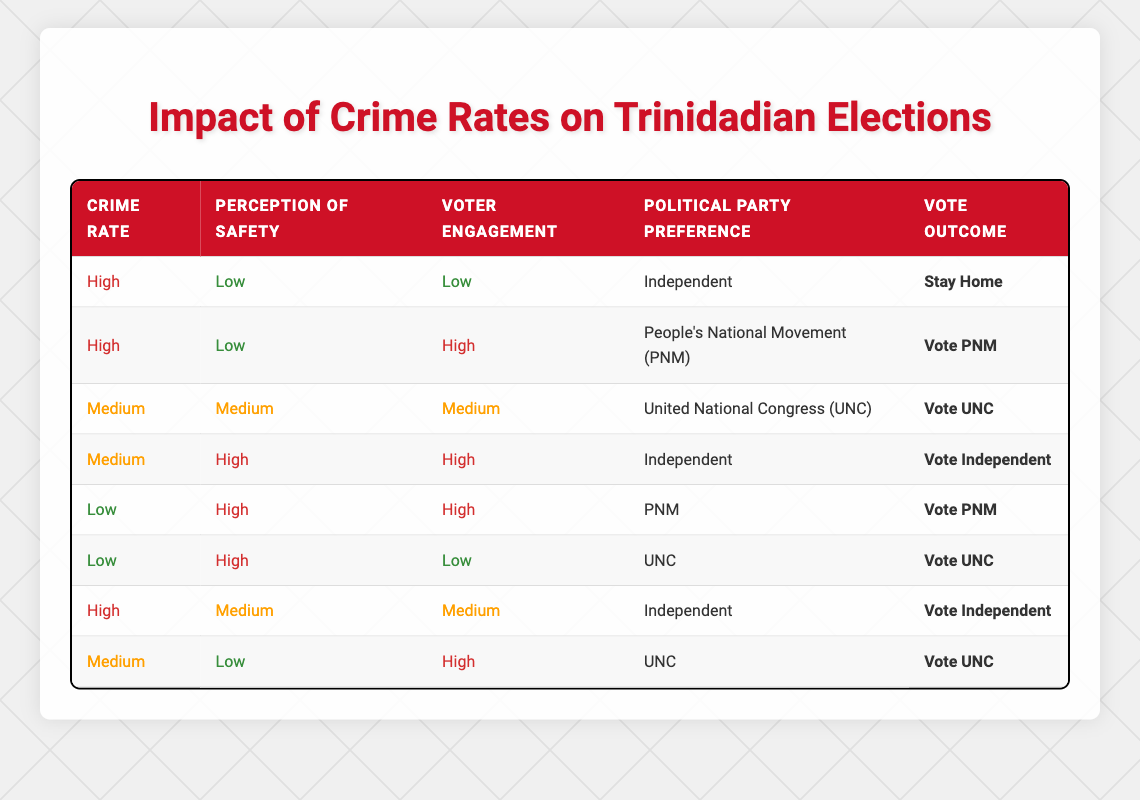What political party do voters prefer when the crime rate is high and their perception of safety is low? In the table, when the crime rate is high and the perception of safety is low, voters' political party preference is either Independent or People's National Movement (PNM). However, the vote outcome indicates that votes go to PNM in the case where voter engagement is high. Therefore, PNM is the preferred party in this specific scenario.
Answer: PNM Is it true that voters with a low perception of safety tend to stay home when the crime rate is high? Yes, the table shows that when crime rates are high and the perception of safety is low, voter engagement is also low, leading to the vote outcome of staying home.
Answer: Yes How many respondents are likely to vote for the United National Congress (UNC) when the crime rate is medium? Looking at the table, there are two scenarios with a medium crime rate: one where perception of safety is medium and voter engagement is medium, resulting in voting for UNC, and another case where perception of safety is low and voter engagement is high, which also results in voting for UNC. Therefore, UNC has a total of 2 outcomes.
Answer: 2 What happens to voter engagement when the crime rate is low and perception of safety is high? According to the table, when the crime rate is low and the perception of safety is high, voter engagement is high. This indicates that in this context, voters feel motivated to engage and participate in the election process.
Answer: High Which outcome do independent voters choose when the crime rate is medium and perception of safety is high? The table indicates that when the crime rate is medium and the perception of safety is high, independent voters will vote for their own party—'Vote Independent' in this scenario.
Answer: Vote Independent What is the vote outcome for UNC when the crime rate is medium and voter engagement is high? In the table, when the crime rate is medium and voter engagement is high, the political party preference is UNC. The vote outcome associated with this preference is 'Vote UNC'.
Answer: Vote UNC How does high voter engagement affect voting outcomes with high crime and low perception of safety? The table indicates that when crime rates are high and the perception of safety is low, there are two cases for voter engagement: low engagement leads to 'Stay Home', whereas high engagement results in voting for PNM. Thus, high voter engagement amidst high crime and low safety leads to voting for PNM.
Answer: Vote PNM Is it correct that having low voter engagement results in voting for UNC when crime is low and safety perception is high? No, the table shows that low voter engagement (when crime is low and perception of safety is high) results in voting for UNC—not true. The result for low engagement in this scenario leads to staying home.
Answer: No 